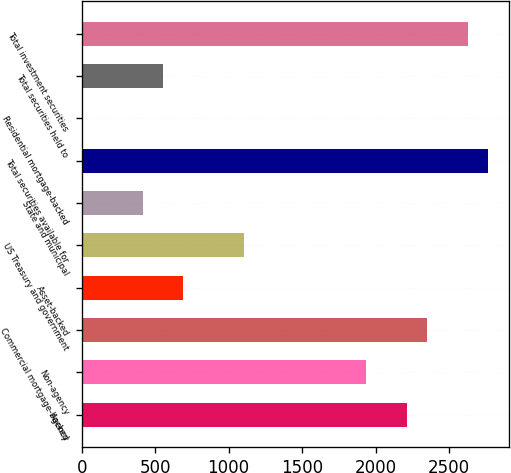Convert chart to OTSL. <chart><loc_0><loc_0><loc_500><loc_500><bar_chart><fcel>Agency<fcel>Non-agency<fcel>Commercial mortgage-backed<fcel>Asset-backed<fcel>US Treasury and government<fcel>State and municipal<fcel>Total securities available for<fcel>Residential mortgage-backed<fcel>Total securities held to<fcel>Total investment securities<nl><fcel>2213.8<fcel>1937.2<fcel>2352.1<fcel>692.5<fcel>1107.4<fcel>415.9<fcel>2767<fcel>1<fcel>554.2<fcel>2628.7<nl></chart> 